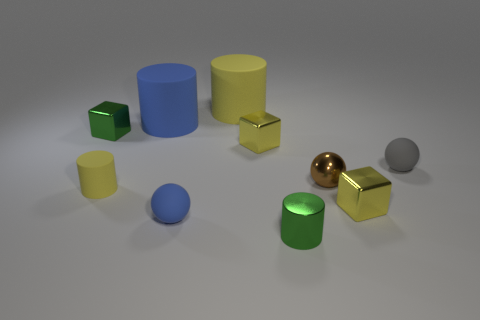Which objects are closest to each other? The two gold cubes are closest to each other, nearly touching. Are there any patterns in the arrangement of these objects? The objects appear to be arranged somewhat randomly, but all are placed on a flat surface with enough space between them, suggesting an intentional setup rather than a haphazard scatter. 